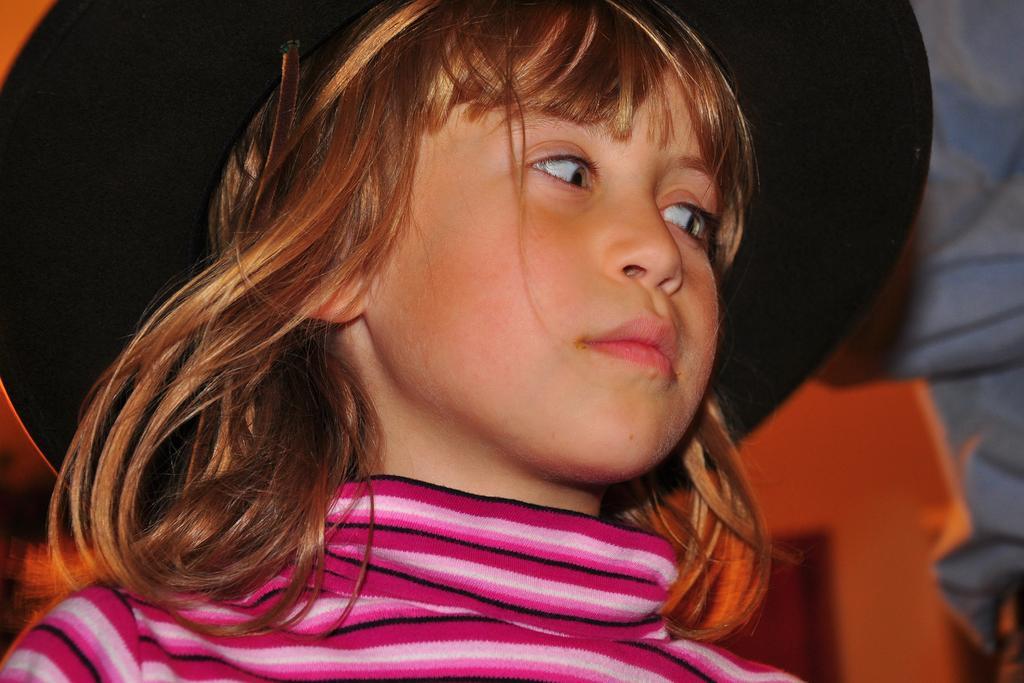Could you give a brief overview of what you see in this image? A person is present wearing a pink and black t shirt with a black hat. She is watching towards right. 